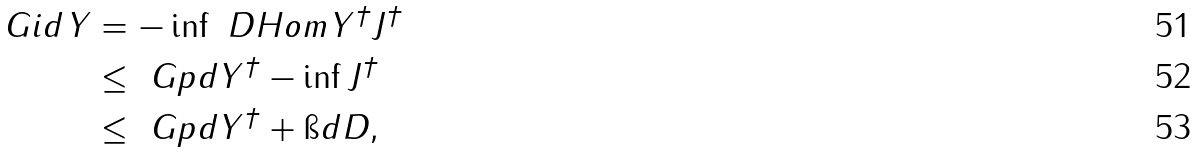<formula> <loc_0><loc_0><loc_500><loc_500>\ G i d { Y } & = - \inf { \ D H o m { Y ^ { \dagger } } { J ^ { \dagger } } } \\ & \leq \ G p d { Y ^ { \dagger } } - \inf { J ^ { \dagger } } \\ & \leq \ G p d { Y ^ { \dagger } } + \i d { D } ,</formula> 